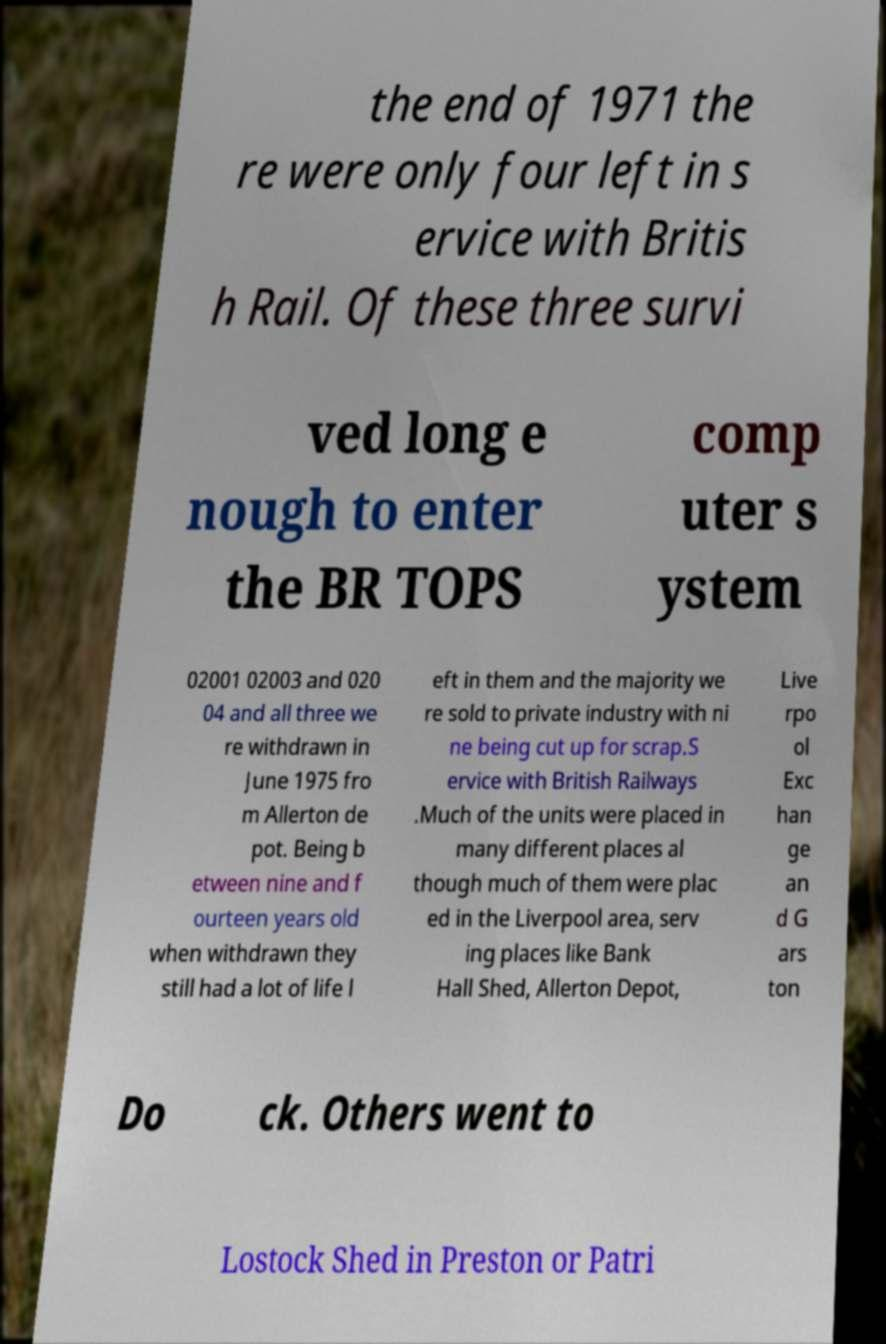Please identify and transcribe the text found in this image. the end of 1971 the re were only four left in s ervice with Britis h Rail. Of these three survi ved long e nough to enter the BR TOPS comp uter s ystem 02001 02003 and 020 04 and all three we re withdrawn in June 1975 fro m Allerton de pot. Being b etween nine and f ourteen years old when withdrawn they still had a lot of life l eft in them and the majority we re sold to private industry with ni ne being cut up for scrap.S ervice with British Railways .Much of the units were placed in many different places al though much of them were plac ed in the Liverpool area, serv ing places like Bank Hall Shed, Allerton Depot, Live rpo ol Exc han ge an d G ars ton Do ck. Others went to Lostock Shed in Preston or Patri 